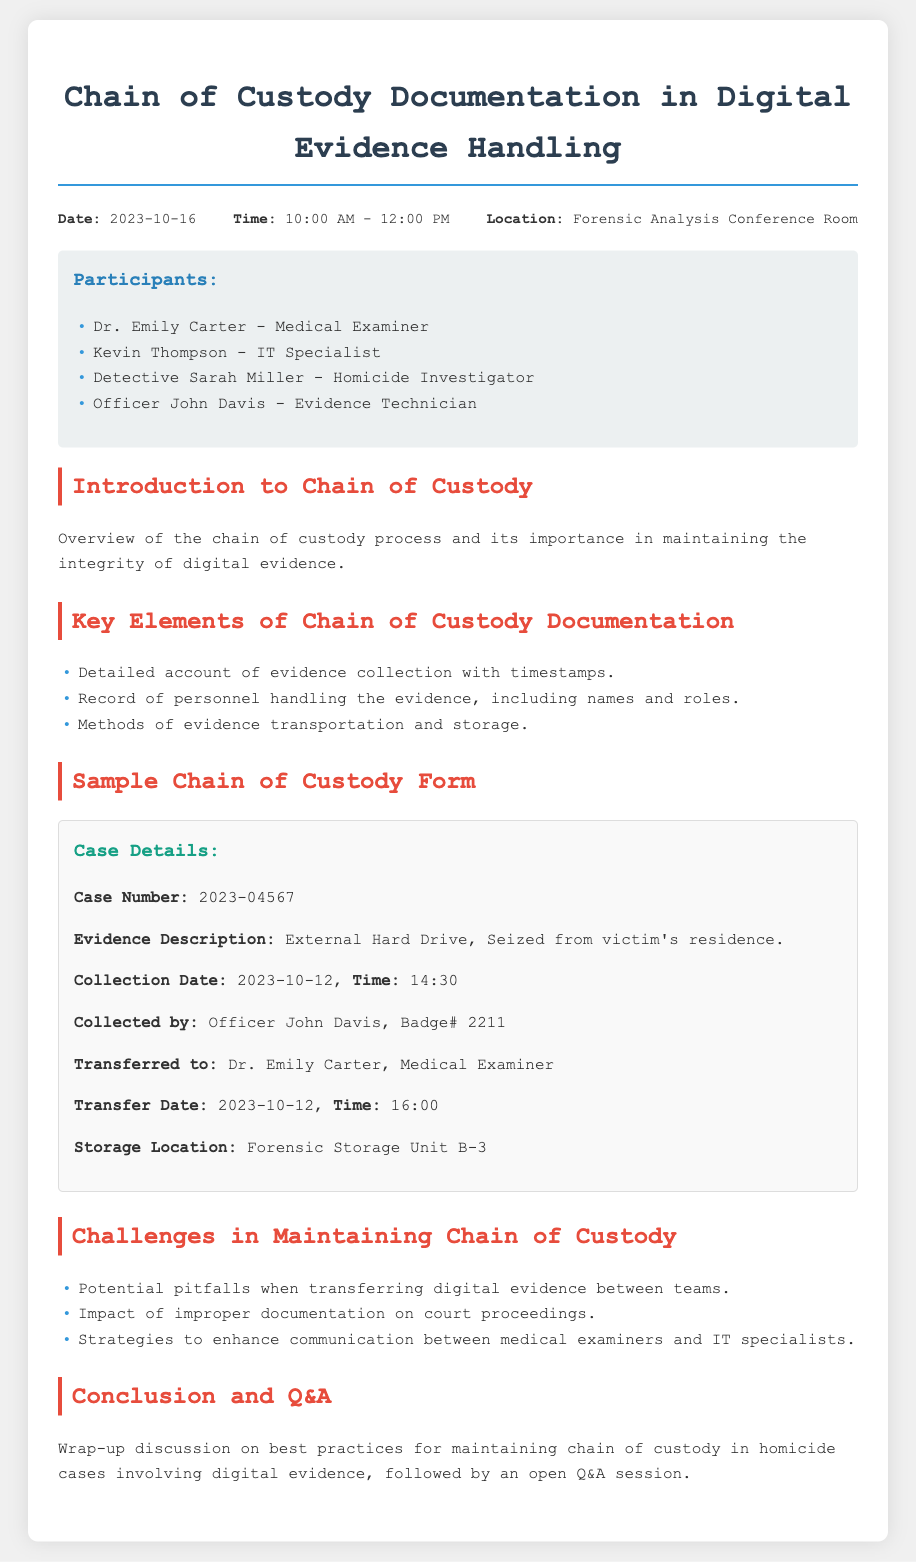What is the date of the meeting? The date of the meeting is indicated in the header info section of the document.
Answer: 2023-10-16 Who is the Medical Examiner? The Medical Examiner’s name is listed under the participants section.
Answer: Dr. Emily Carter What is the evidence description? The evidence description is provided in the sample chain of custody form within the document.
Answer: External Hard Drive, Seized from victim's residence What time was the evidence collected? The collection time is noted in the sample chain of custody form.
Answer: 14:30 Who transferred the evidence to the Medical Examiner? The person responsible for transferring the evidence is mentioned in the sample chain of custody form.
Answer: Officer John Davis What is the storage location of the evidence? The storage location is specified in the sample chain of custody form.
Answer: Forensic Storage Unit B-3 What challenge is mentioned regarding chain of custody? The challenges are listed in the section dedicated to maintaining the chain of custody.
Answer: Potential pitfalls when transferring digital evidence between teams How long was the meeting scheduled for? The meeting duration can be determined by subtracting the start time from the end time.
Answer: 2 hours What is the case number referenced in the document? The case number appears in the sample chain of custody form.
Answer: 2023-04567 